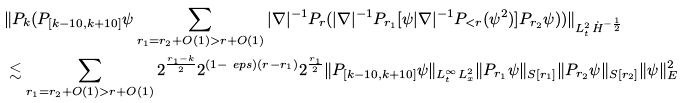Convert formula to latex. <formula><loc_0><loc_0><loc_500><loc_500>& \| P _ { k } ( P _ { [ k - 1 0 , k + 1 0 ] } \psi \sum _ { r _ { 1 } = r _ { 2 } + O ( 1 ) > r + O ( 1 ) } | \nabla | ^ { - 1 } P _ { r } ( | \nabla | ^ { - 1 } P _ { r _ { 1 } } [ \psi | \nabla | ^ { - 1 } P _ { < r } ( \psi ^ { 2 } ) ] P _ { r _ { 2 } } \psi ) ) \| _ { L _ { t } ^ { 2 } \dot { H } ^ { - \frac { 1 } { 2 } } } \\ & \lesssim \sum _ { r _ { 1 } = r _ { 2 } + O ( 1 ) > r + O ( 1 ) } 2 ^ { \frac { r _ { 1 } - k } { 2 } } 2 ^ { ( 1 - \ e p s ) ( r - r _ { 1 } ) } 2 ^ { \frac { r _ { 1 } } { 2 } } \| P _ { [ k - 1 0 , k + 1 0 ] } \psi \| _ { L _ { t } ^ { \infty } L _ { x } ^ { 2 } } \| P _ { r _ { 1 } } \psi \| _ { S [ r _ { 1 } ] } \| P _ { r _ { 2 } } \psi \| _ { S [ r _ { 2 } ] } \| \psi \| _ { E } ^ { 2 }</formula> 